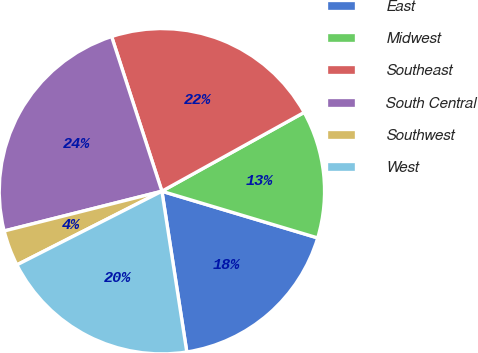<chart> <loc_0><loc_0><loc_500><loc_500><pie_chart><fcel>East<fcel>Midwest<fcel>Southeast<fcel>South Central<fcel>Southwest<fcel>West<nl><fcel>17.92%<fcel>12.69%<fcel>21.95%<fcel>23.93%<fcel>3.55%<fcel>19.97%<nl></chart> 